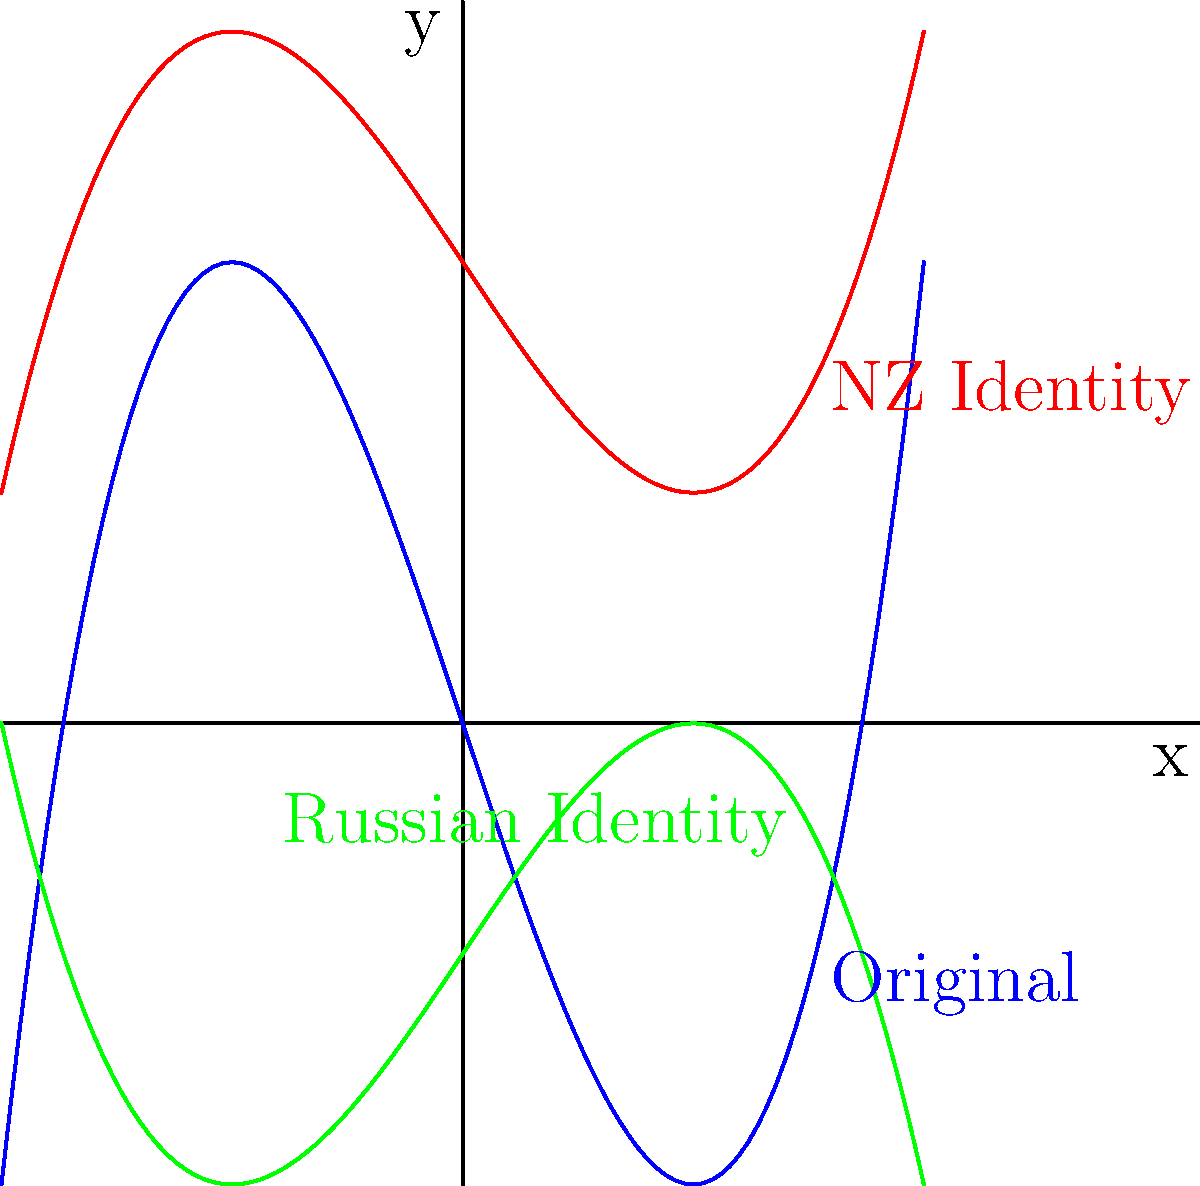The graph shows three polynomial functions representing different stages of an adoptee's identity journey. The blue curve represents the original identity, the red curve represents the New Zealand identity, and the green curve represents the Russian identity. If the original function is $f(x)=x^3-3x$, what transformations were applied to create the functions representing the New Zealand and Russian identities? Let's approach this step-by-step:

1) The original function is $f(x)=x^3-3x$ (blue curve).

2) For the New Zealand identity (red curve):
   - It appears to be vertically compressed by a factor of 0.5
   - It is shifted up by 2 units
   So, the function for the New Zealand identity is:
   $g(x) = 0.5f(x) + 2 = 0.5(x^3-3x) + 2$

3) For the Russian identity (green curve):
   - It appears to be vertically compressed by a factor of 0.5
   - It is reflected over the x-axis (multiplied by -1)
   - It is shifted down by 1 unit
   So, the function for the Russian identity is:
   $h(x) = -0.5f(x) - 1 = -0.5(x^3-3x) - 1$

4) To summarize the transformations:
   - New Zealand identity: vertical compression by 0.5 and vertical shift up by 2
   - Russian identity: vertical compression by 0.5, reflection over x-axis, and vertical shift down by 1
Answer: NZ: $0.5f(x)+2$; Russian: $-0.5f(x)-1$ 